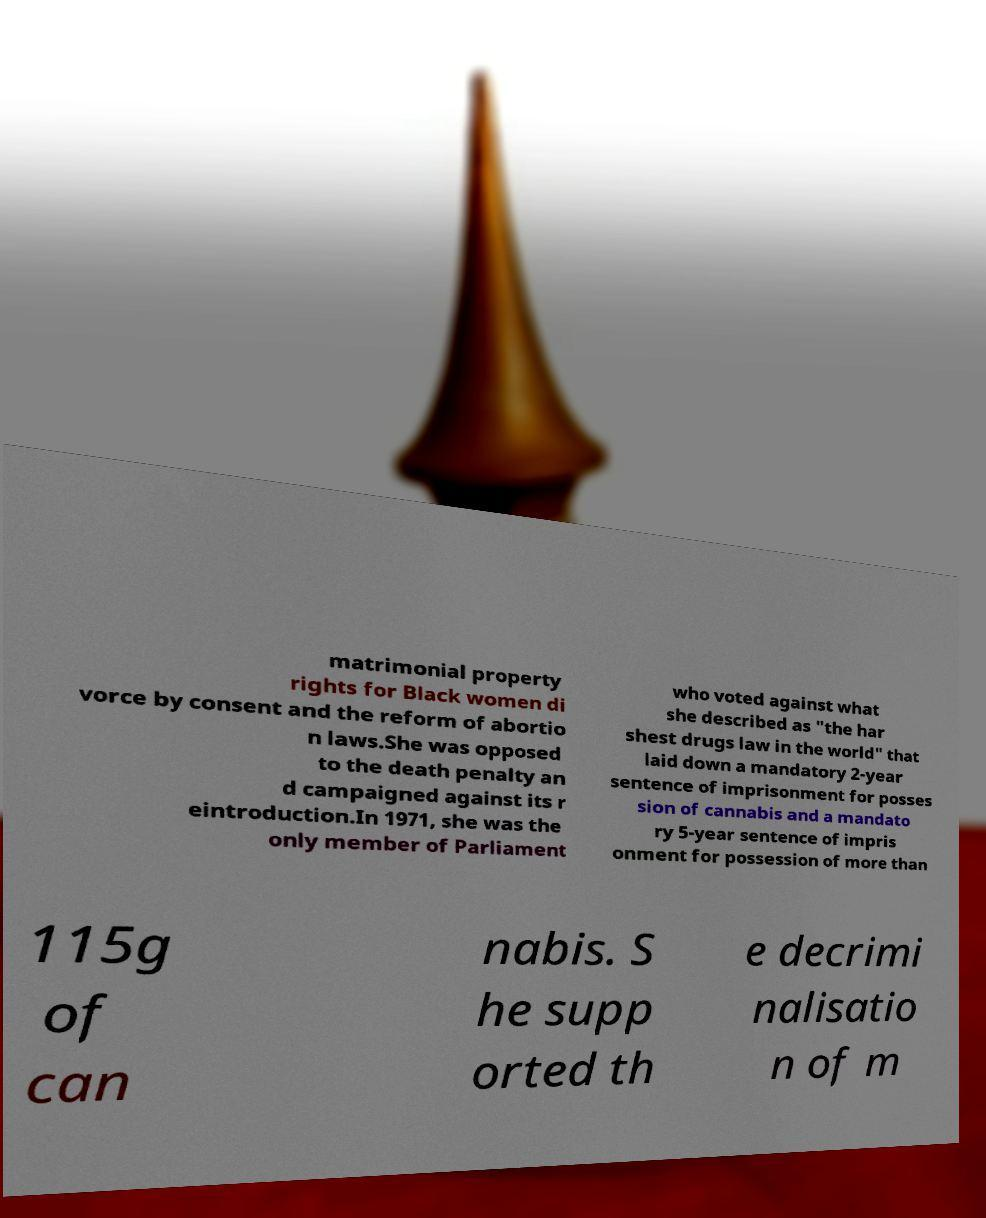Could you assist in decoding the text presented in this image and type it out clearly? matrimonial property rights for Black women di vorce by consent and the reform of abortio n laws.She was opposed to the death penalty an d campaigned against its r eintroduction.In 1971, she was the only member of Parliament who voted against what she described as "the har shest drugs law in the world" that laid down a mandatory 2-year sentence of imprisonment for posses sion of cannabis and a mandato ry 5-year sentence of impris onment for possession of more than 115g of can nabis. S he supp orted th e decrimi nalisatio n of m 